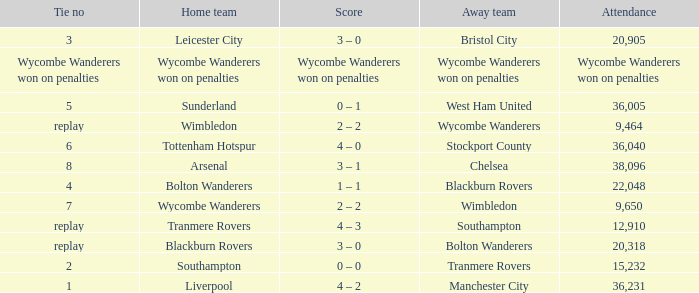What was the score for the game where the home team was Wycombe Wanderers? 2 – 2. 